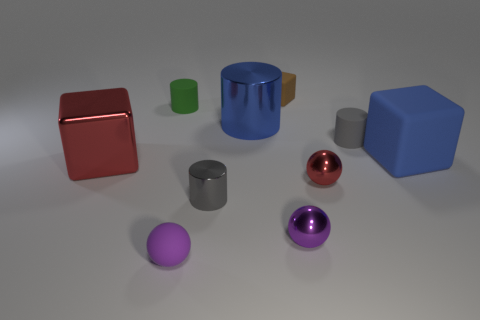How many objects are large blue rubber objects or cylinders behind the big red metal thing? Assessing the objects in the image while considering both size and texture, as well as their location relative to the big red object that appears to be metallic, there are two objects that could be considered large, blue, and rubbery, and one cylinder located behind the red object. Thus, the total count is three, not four. 